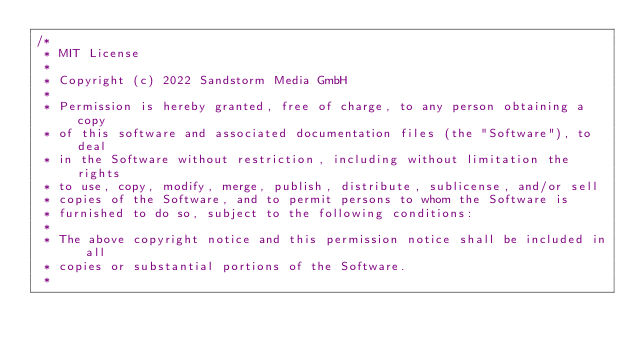<code> <loc_0><loc_0><loc_500><loc_500><_Kotlin_>/*
 * MIT License
 *
 * Copyright (c) 2022 Sandstorm Media GmbH
 *
 * Permission is hereby granted, free of charge, to any person obtaining a copy
 * of this software and associated documentation files (the "Software"), to deal
 * in the Software without restriction, including without limitation the rights
 * to use, copy, modify, merge, publish, distribute, sublicense, and/or sell
 * copies of the Software, and to permit persons to whom the Software is
 * furnished to do so, subject to the following conditions:
 *
 * The above copyright notice and this permission notice shall be included in all
 * copies or substantial portions of the Software.
 *</code> 